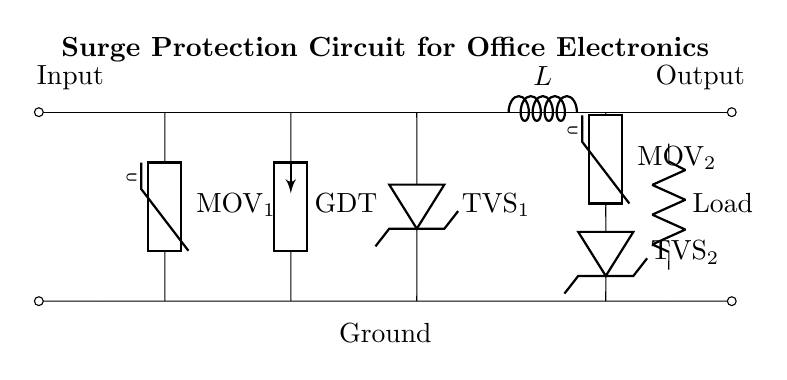What does MOV stand for in this circuit? MOV stands for Metal Oxide Varistor, which is a protective device used to clamp voltage spikes and protect equipment from surges.
Answer: Metal Oxide Varistor How many surge protection devices are in this circuit? The circuit contains four surge protection devices: two MOVs, one gas discharge tube, and two TVS diodes.
Answer: Four What type of load is represented in this circuit? The load is represented as a resistor, symbolizing the equipment being protected from voltage surges.
Answer: Resistor What is the function of the inductor in this circuit? The inductor serves to limit the rate of change of current in the event of a surge, providing additional protection to the connected load.
Answer: Limit current What is the role of the gas discharge tube in surge protection? The gas discharge tube acts as a surge arrester that conducts excess voltage away from sensitive equipment, thus preventing damage.
Answer: Conducts excess voltage Where is the ground connection in the circuit? The ground connection is located at the bottom of the circuit diagram, running parallel to the main power line, indicated by the horizontal line at the bottom.
Answer: Bottom of the circuit What components are used to provide redundancy for surge protection? The circuit uses two MOVs and two TVS diodes, providing multiple layers of protection against voltage surges.
Answer: Two MOVs and two TVS diodes 